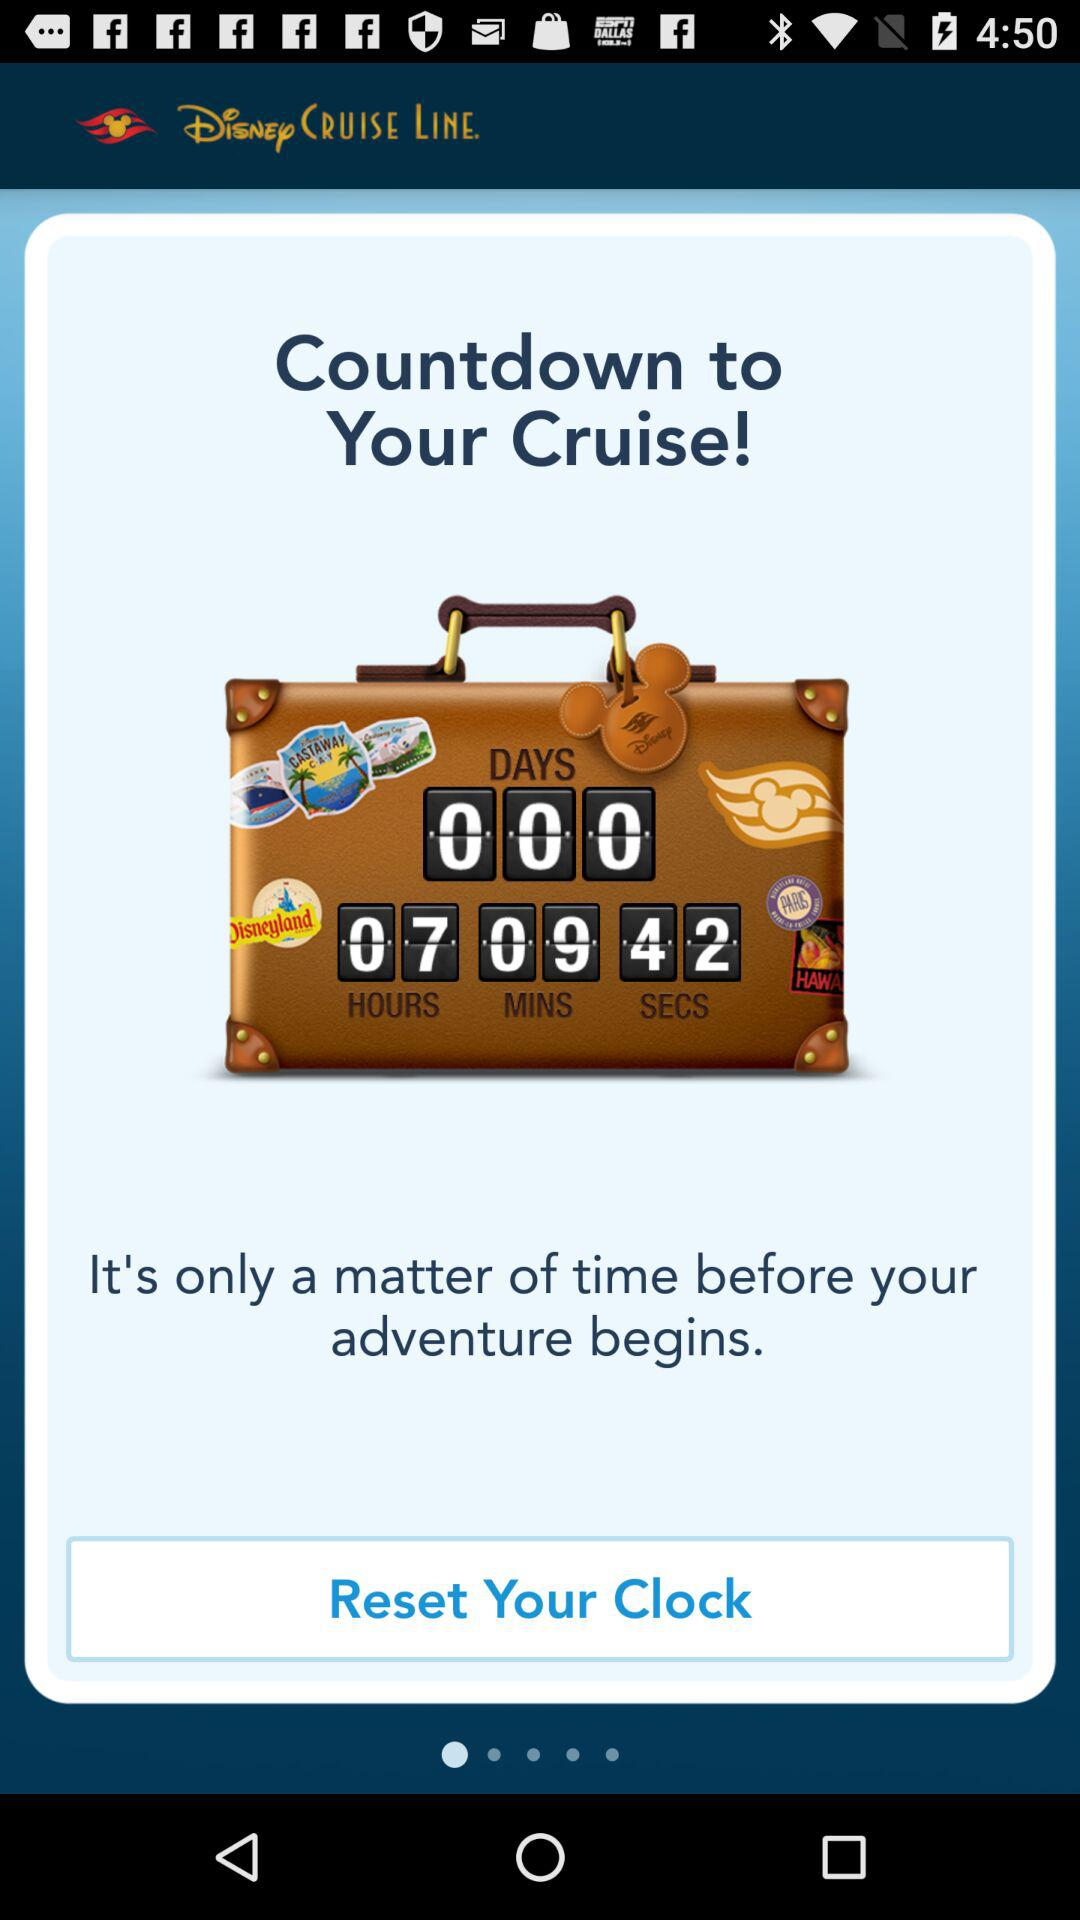How many seconds are left for the countdown to your cruise? There are 42 seconds left. 